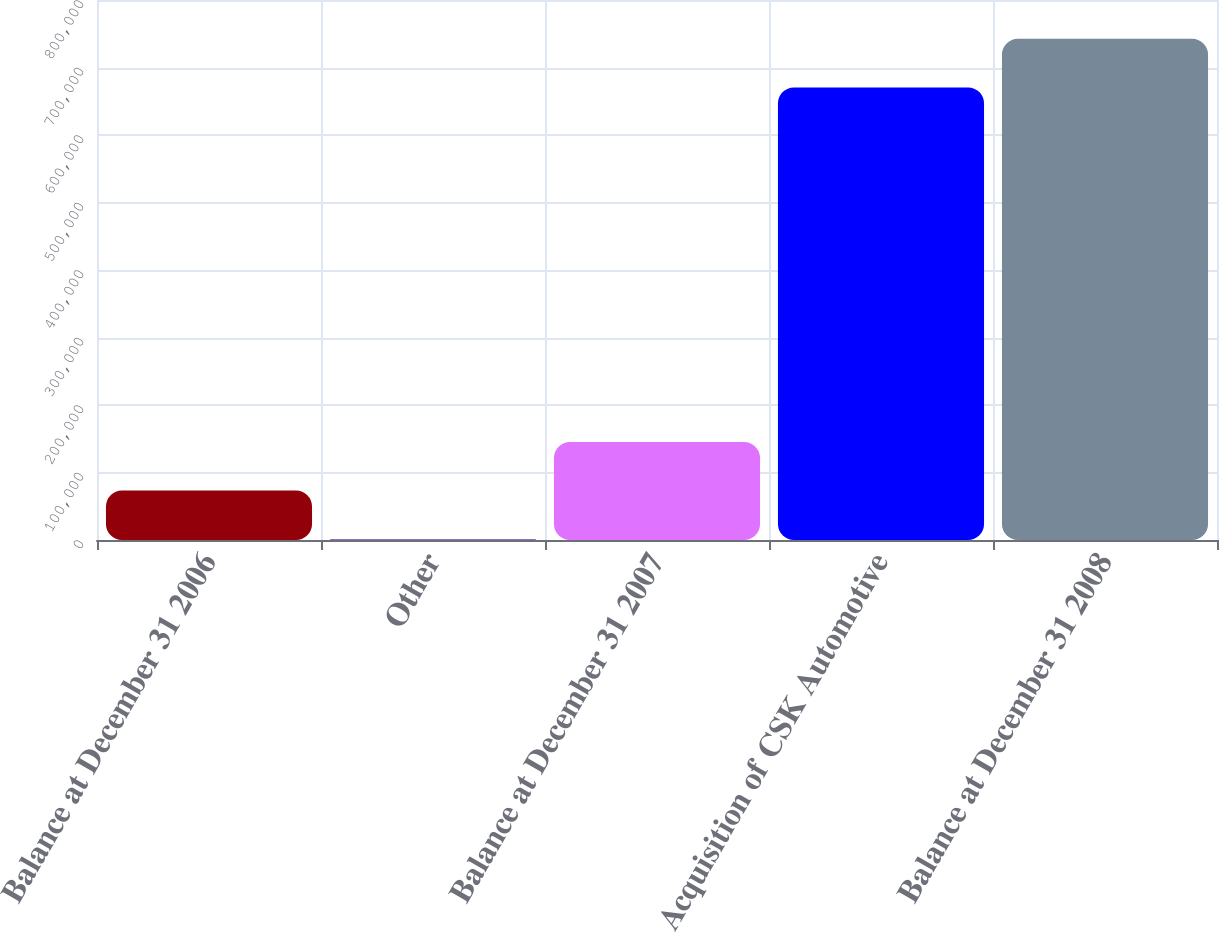Convert chart. <chart><loc_0><loc_0><loc_500><loc_500><bar_chart><fcel>Balance at December 31 2006<fcel>Other<fcel>Balance at December 31 2007<fcel>Acquisition of CSK Automotive<fcel>Balance at December 31 2008<nl><fcel>73294.6<fcel>1382<fcel>145207<fcel>670508<fcel>742421<nl></chart> 